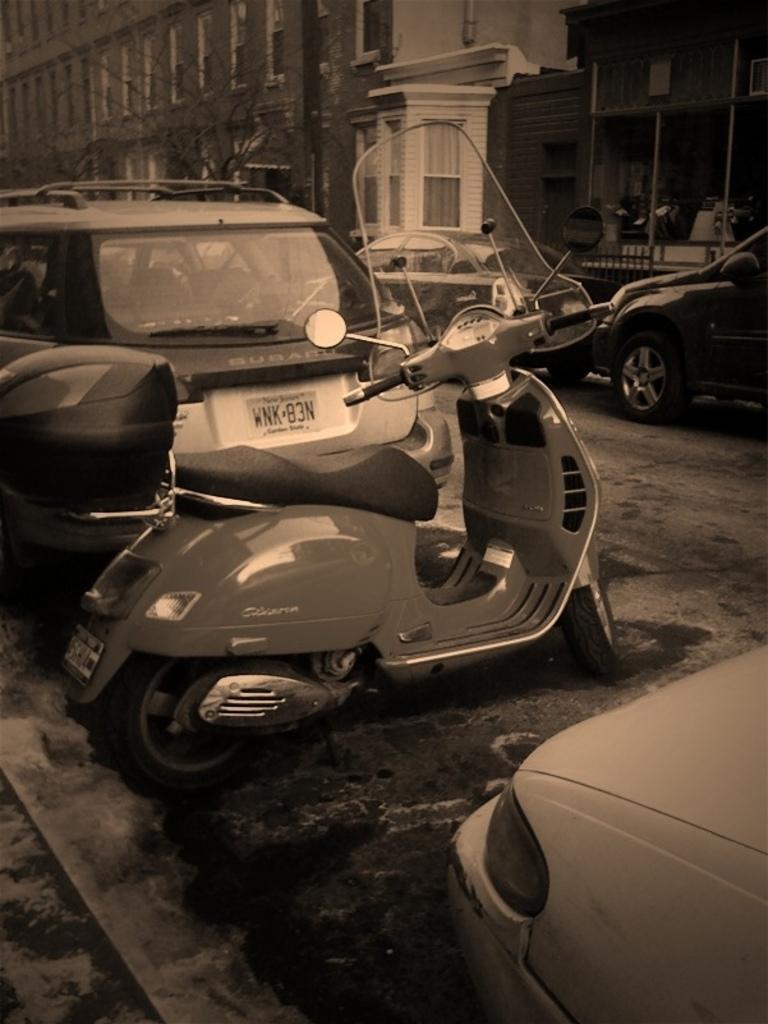Can you describe this image briefly? It is a black and white picture. In this picture there are vehicles, buildings, trees and objects.  